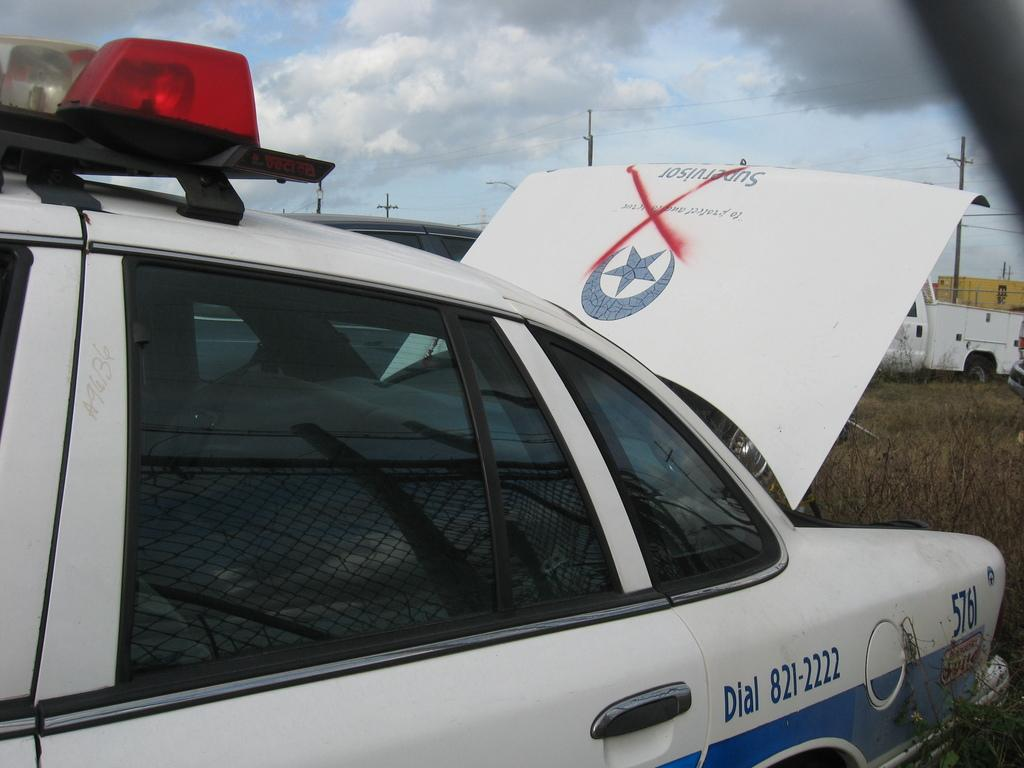<image>
Relay a brief, clear account of the picture shown. A police car has the trunk up and a red X grafittied across the word Supervisor and says Dial 821-2222 on the side. 